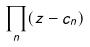Convert formula to latex. <formula><loc_0><loc_0><loc_500><loc_500>\prod _ { n } ( z - c _ { n } )</formula> 